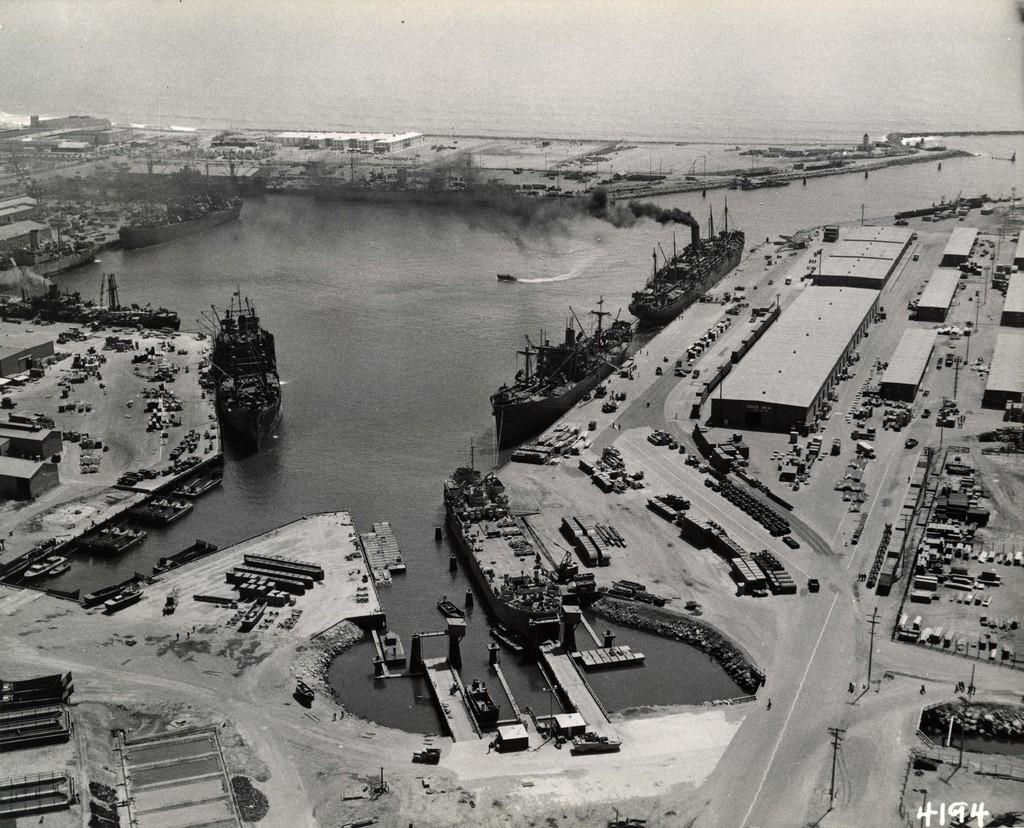What is the color scheme of the image? The image is black and white. What can be seen on the road in the image? There are vehicles on the road in the image. What can be seen on the water in the image? There are boats on the water in the image. What type of structures can be seen in the image? There are buildings and sheds in the image. What else can be seen in the image? There are poles and other objects in the image. How many grains of sand can be seen on the calculator in the image? There is no calculator or sand present in the image. 